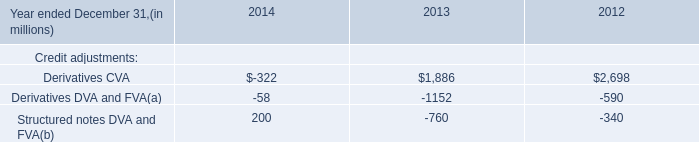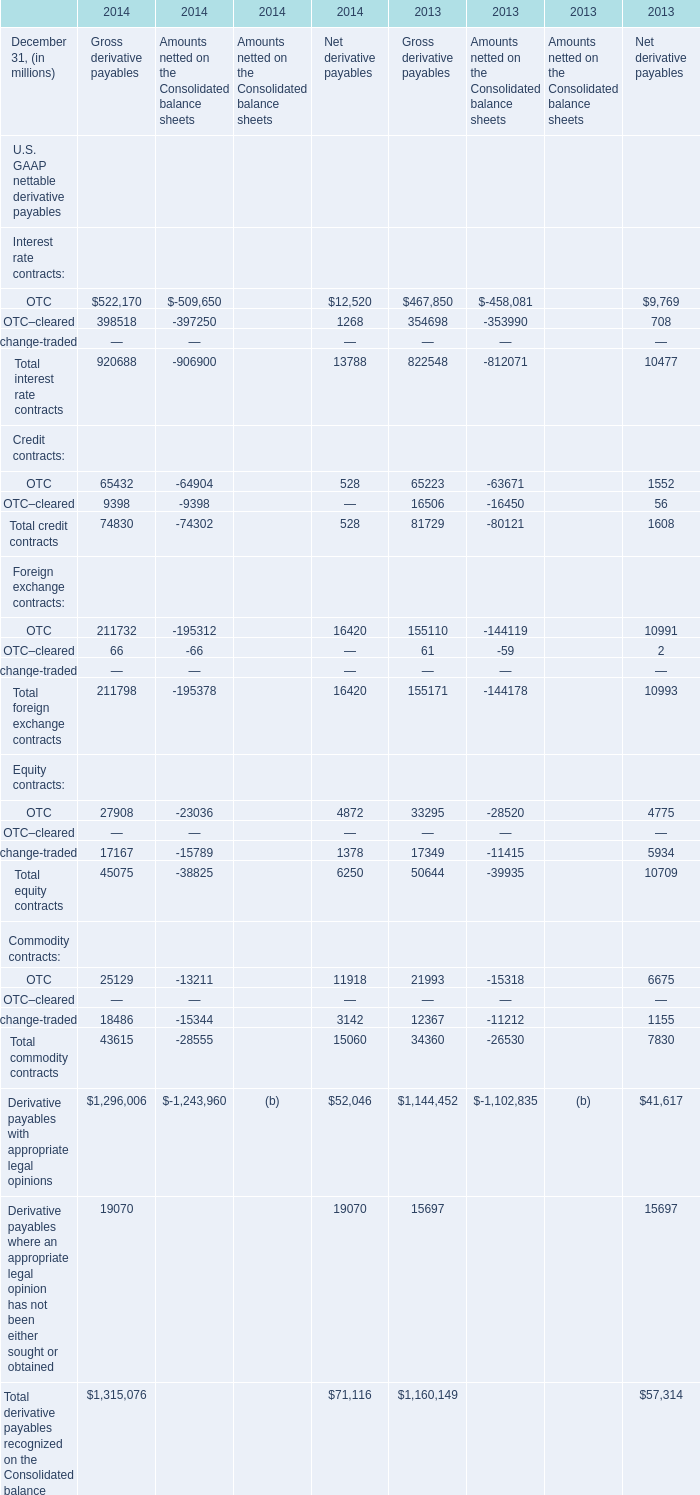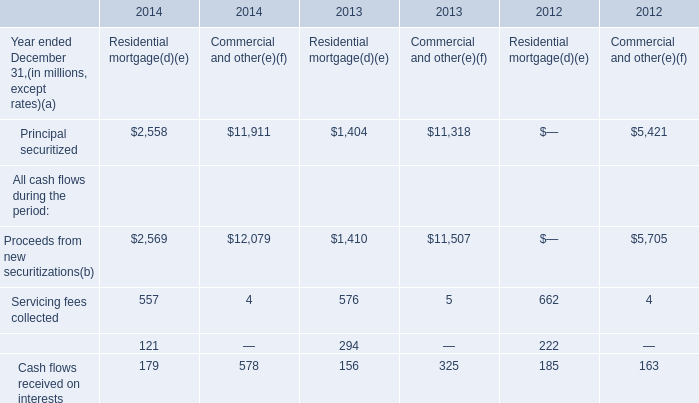What's the average of the Principal securitized in the years where OTC is positive? 
Computations: ((((2558 + 11911) + 1404) + 11318) / 4)
Answer: 6797.75. 